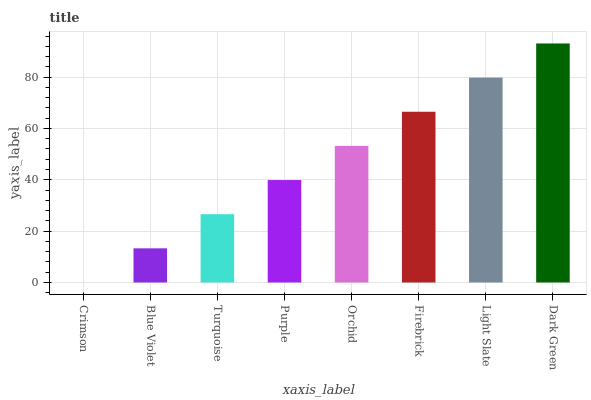Is Crimson the minimum?
Answer yes or no. Yes. Is Dark Green the maximum?
Answer yes or no. Yes. Is Blue Violet the minimum?
Answer yes or no. No. Is Blue Violet the maximum?
Answer yes or no. No. Is Blue Violet greater than Crimson?
Answer yes or no. Yes. Is Crimson less than Blue Violet?
Answer yes or no. Yes. Is Crimson greater than Blue Violet?
Answer yes or no. No. Is Blue Violet less than Crimson?
Answer yes or no. No. Is Orchid the high median?
Answer yes or no. Yes. Is Purple the low median?
Answer yes or no. Yes. Is Firebrick the high median?
Answer yes or no. No. Is Turquoise the low median?
Answer yes or no. No. 